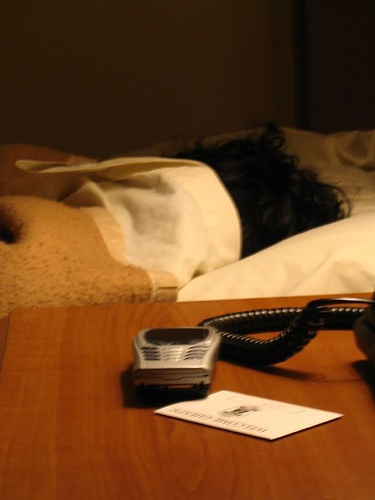Describe the objects in this image and their specific colors. I can see bed in black, tan, red, and maroon tones, people in black, maroon, and tan tones, and cell phone in black, maroon, and tan tones in this image. 